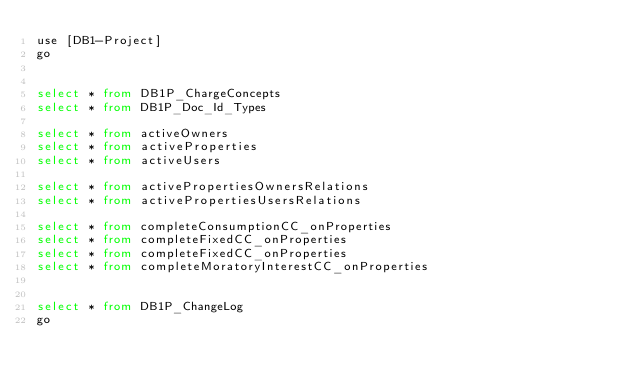Convert code to text. <code><loc_0><loc_0><loc_500><loc_500><_SQL_>use [DB1-Project]
go


select * from DB1P_ChargeConcepts
select * from DB1P_Doc_Id_Types

select * from activeOwners
select * from activeProperties
select * from activeUsers

select * from activePropertiesOwnersRelations
select * from activePropertiesUsersRelations

select * from completeConsumptionCC_onProperties
select * from completeFixedCC_onProperties
select * from completeFixedCC_onProperties
select * from completeMoratoryInterestCC_onProperties


select * from DB1P_ChangeLog
go</code> 